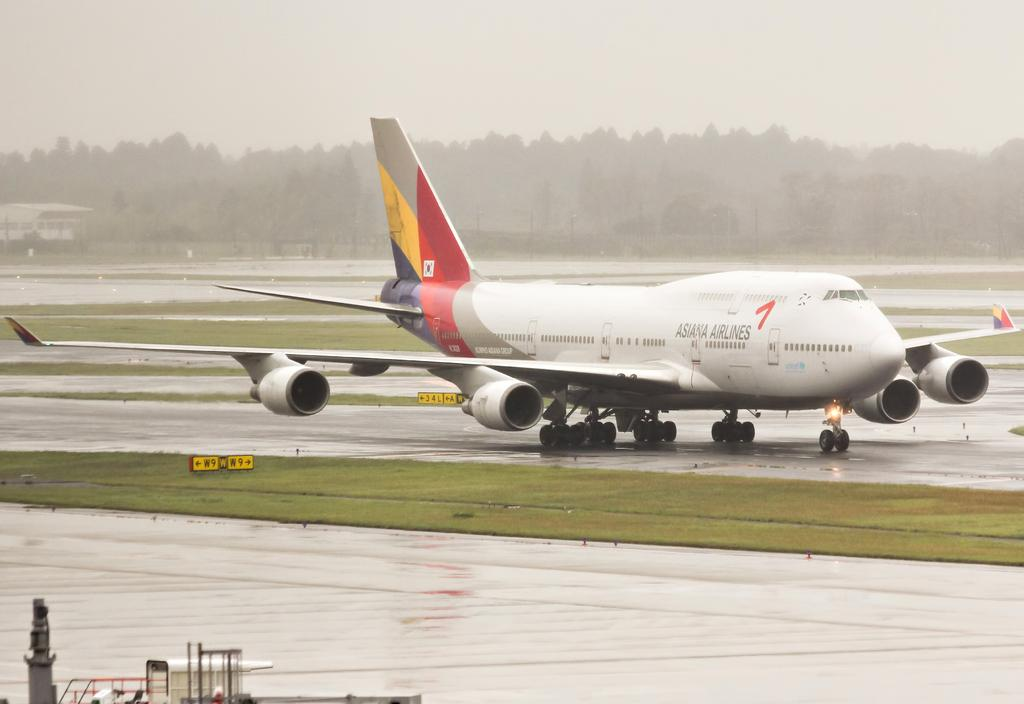<image>
Give a short and clear explanation of the subsequent image. Asiana Airlines is taxing on the wet runway. 